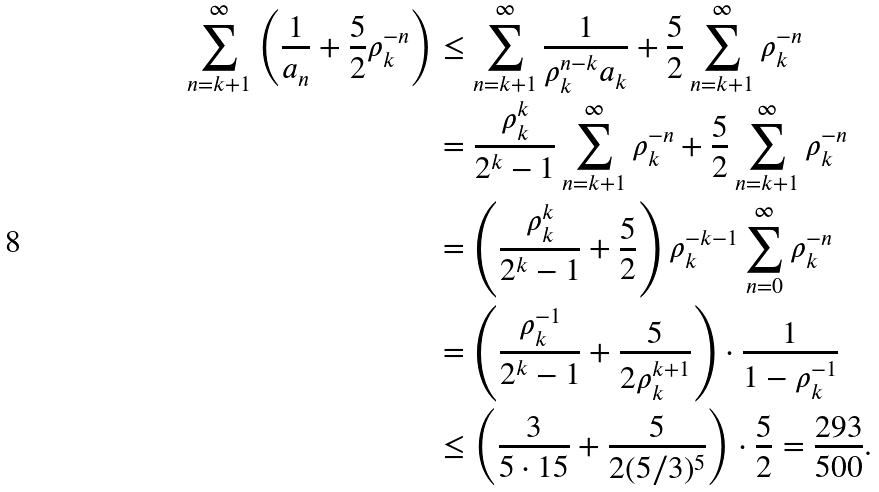Convert formula to latex. <formula><loc_0><loc_0><loc_500><loc_500>\sum _ { n = k + 1 } ^ { \infty } \left ( \frac { 1 } { a _ { n } } + \frac { 5 } { 2 } \rho _ { k } ^ { - n } \right ) & \leq \sum _ { n = k + 1 } ^ { \infty } \frac { 1 } { \rho _ { k } ^ { n - k } a _ { k } } + \frac { 5 } { 2 } \sum _ { n = k + 1 } ^ { \infty } \rho _ { k } ^ { - n } \\ & = \frac { \rho _ { k } ^ { k } } { 2 ^ { k } - 1 } \sum _ { n = k + 1 } ^ { \infty } \rho _ { k } ^ { - n } + \frac { 5 } { 2 } \sum _ { n = k + 1 } ^ { \infty } \rho _ { k } ^ { - n } \\ & = \left ( \frac { \rho _ { k } ^ { k } } { 2 ^ { k } - 1 } + \frac { 5 } { 2 } \right ) \rho _ { k } ^ { - k - 1 } \sum _ { n = 0 } ^ { \infty } \rho _ { k } ^ { - n } \\ & = \left ( \frac { \rho _ { k } ^ { - 1 } } { 2 ^ { k } - 1 } + \frac { 5 } { 2 \rho _ { k } ^ { k + 1 } } \right ) \cdot \frac { 1 } { 1 - \rho _ { k } ^ { - 1 } } \\ & \leq \left ( \frac { 3 } { 5 \cdot 1 5 } + \frac { 5 } { 2 ( 5 / 3 ) ^ { 5 } } \right ) \cdot \frac { 5 } { 2 } = \frac { 2 9 3 } { 5 0 0 } .</formula> 